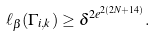<formula> <loc_0><loc_0><loc_500><loc_500>\ell _ { \beta } ( \Gamma _ { i , k } ) \geq \delta ^ { 2 e ^ { 2 ( 2 N + 1 4 ) } } .</formula> 